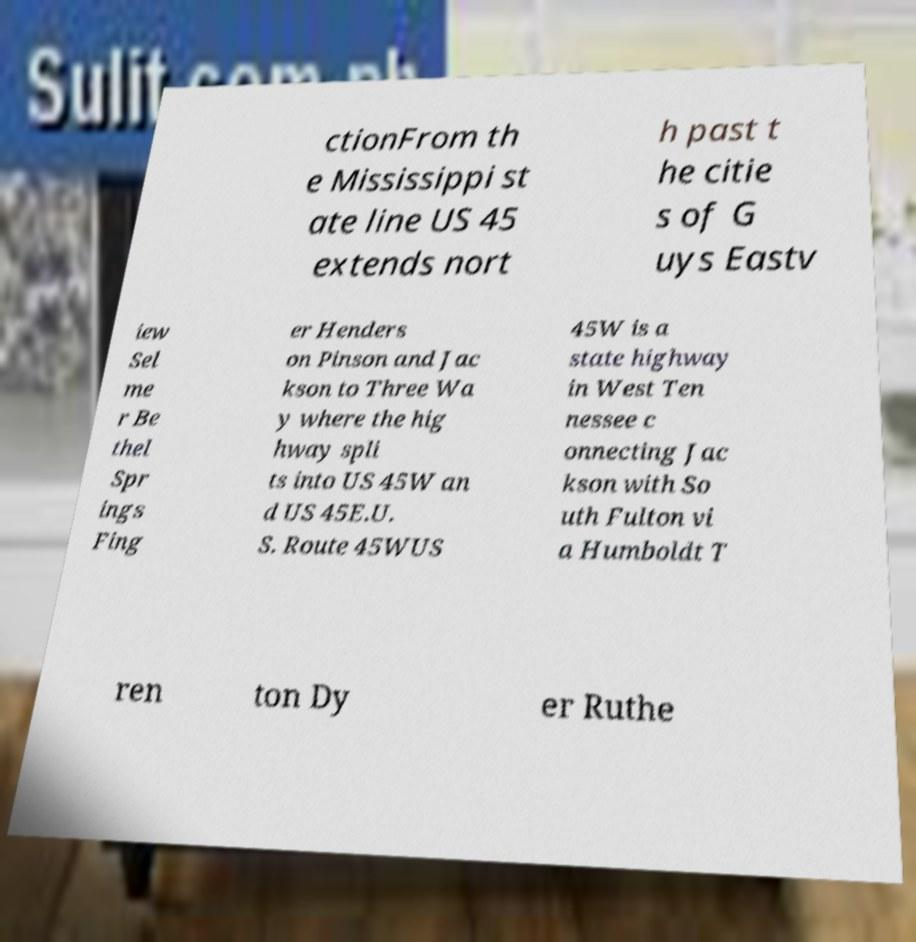What messages or text are displayed in this image? I need them in a readable, typed format. ctionFrom th e Mississippi st ate line US 45 extends nort h past t he citie s of G uys Eastv iew Sel me r Be thel Spr ings Fing er Henders on Pinson and Jac kson to Three Wa y where the hig hway spli ts into US 45W an d US 45E.U. S. Route 45WUS 45W is a state highway in West Ten nessee c onnecting Jac kson with So uth Fulton vi a Humboldt T ren ton Dy er Ruthe 